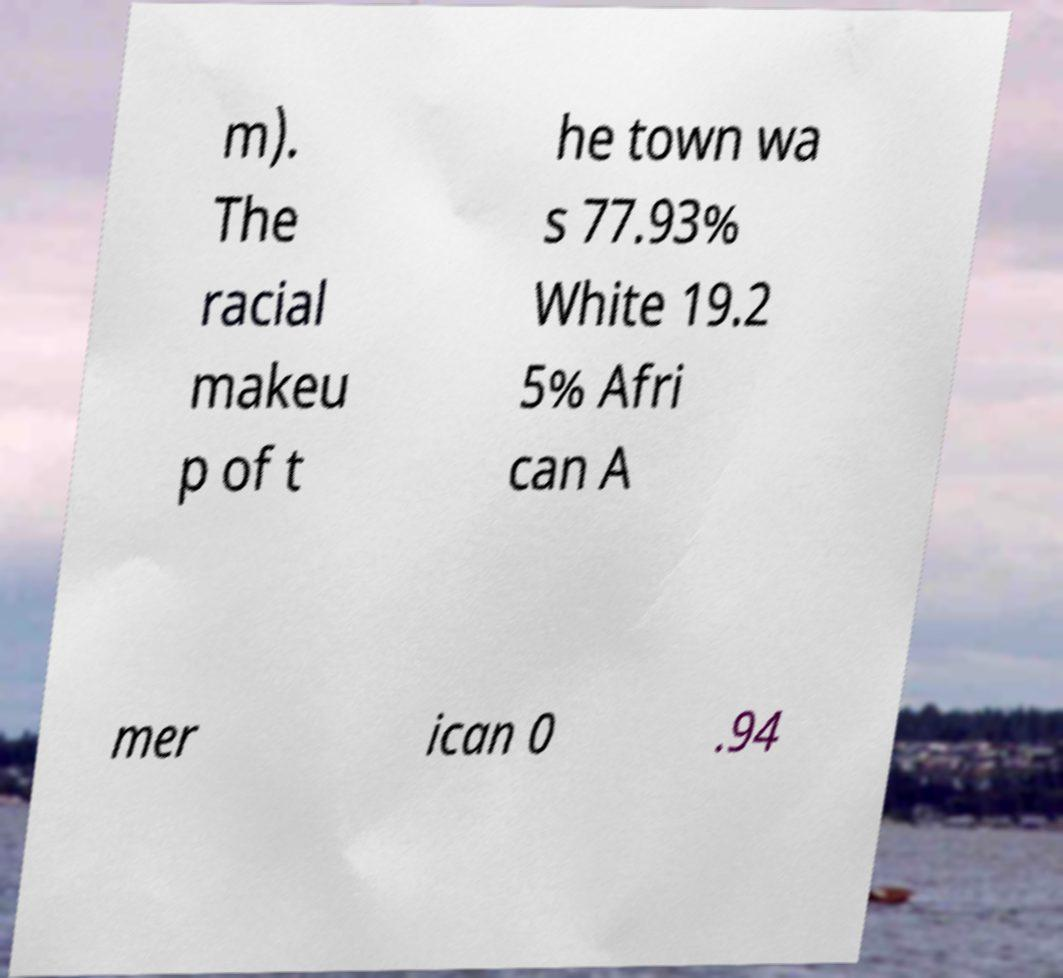Please identify and transcribe the text found in this image. m). The racial makeu p of t he town wa s 77.93% White 19.2 5% Afri can A mer ican 0 .94 